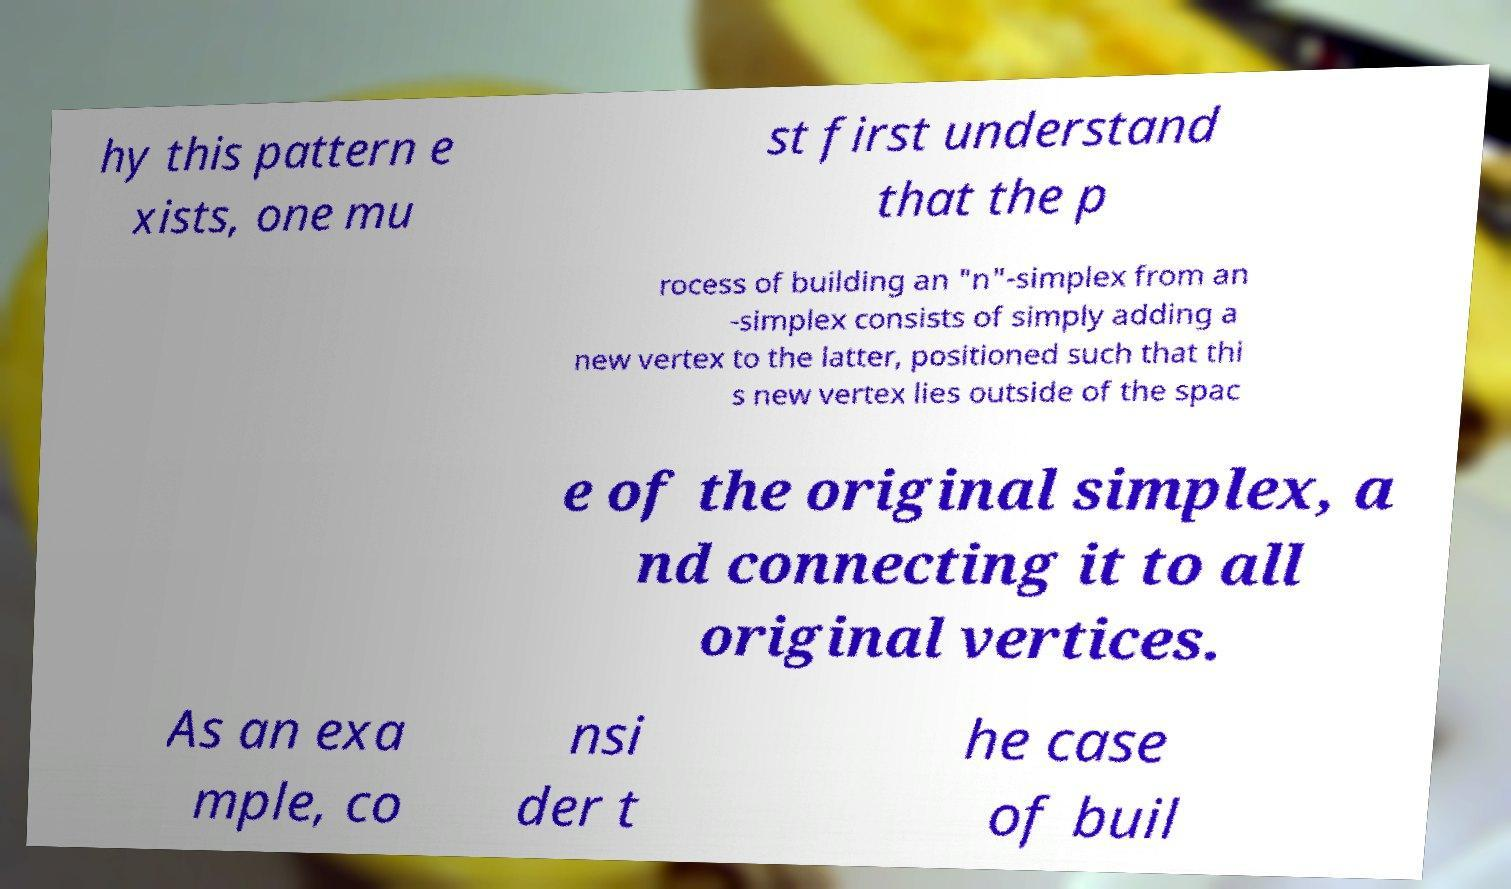Please read and relay the text visible in this image. What does it say? hy this pattern e xists, one mu st first understand that the p rocess of building an "n"-simplex from an -simplex consists of simply adding a new vertex to the latter, positioned such that thi s new vertex lies outside of the spac e of the original simplex, a nd connecting it to all original vertices. As an exa mple, co nsi der t he case of buil 